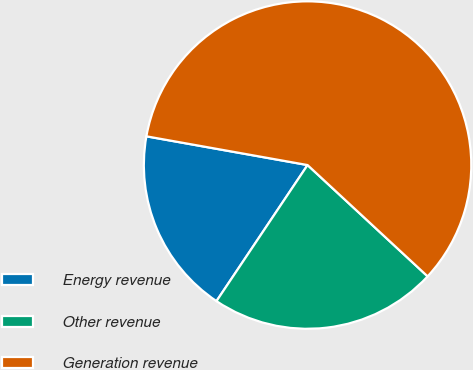Convert chart. <chart><loc_0><loc_0><loc_500><loc_500><pie_chart><fcel>Energy revenue<fcel>Other revenue<fcel>Generation revenue<nl><fcel>18.42%<fcel>22.49%<fcel>59.09%<nl></chart> 